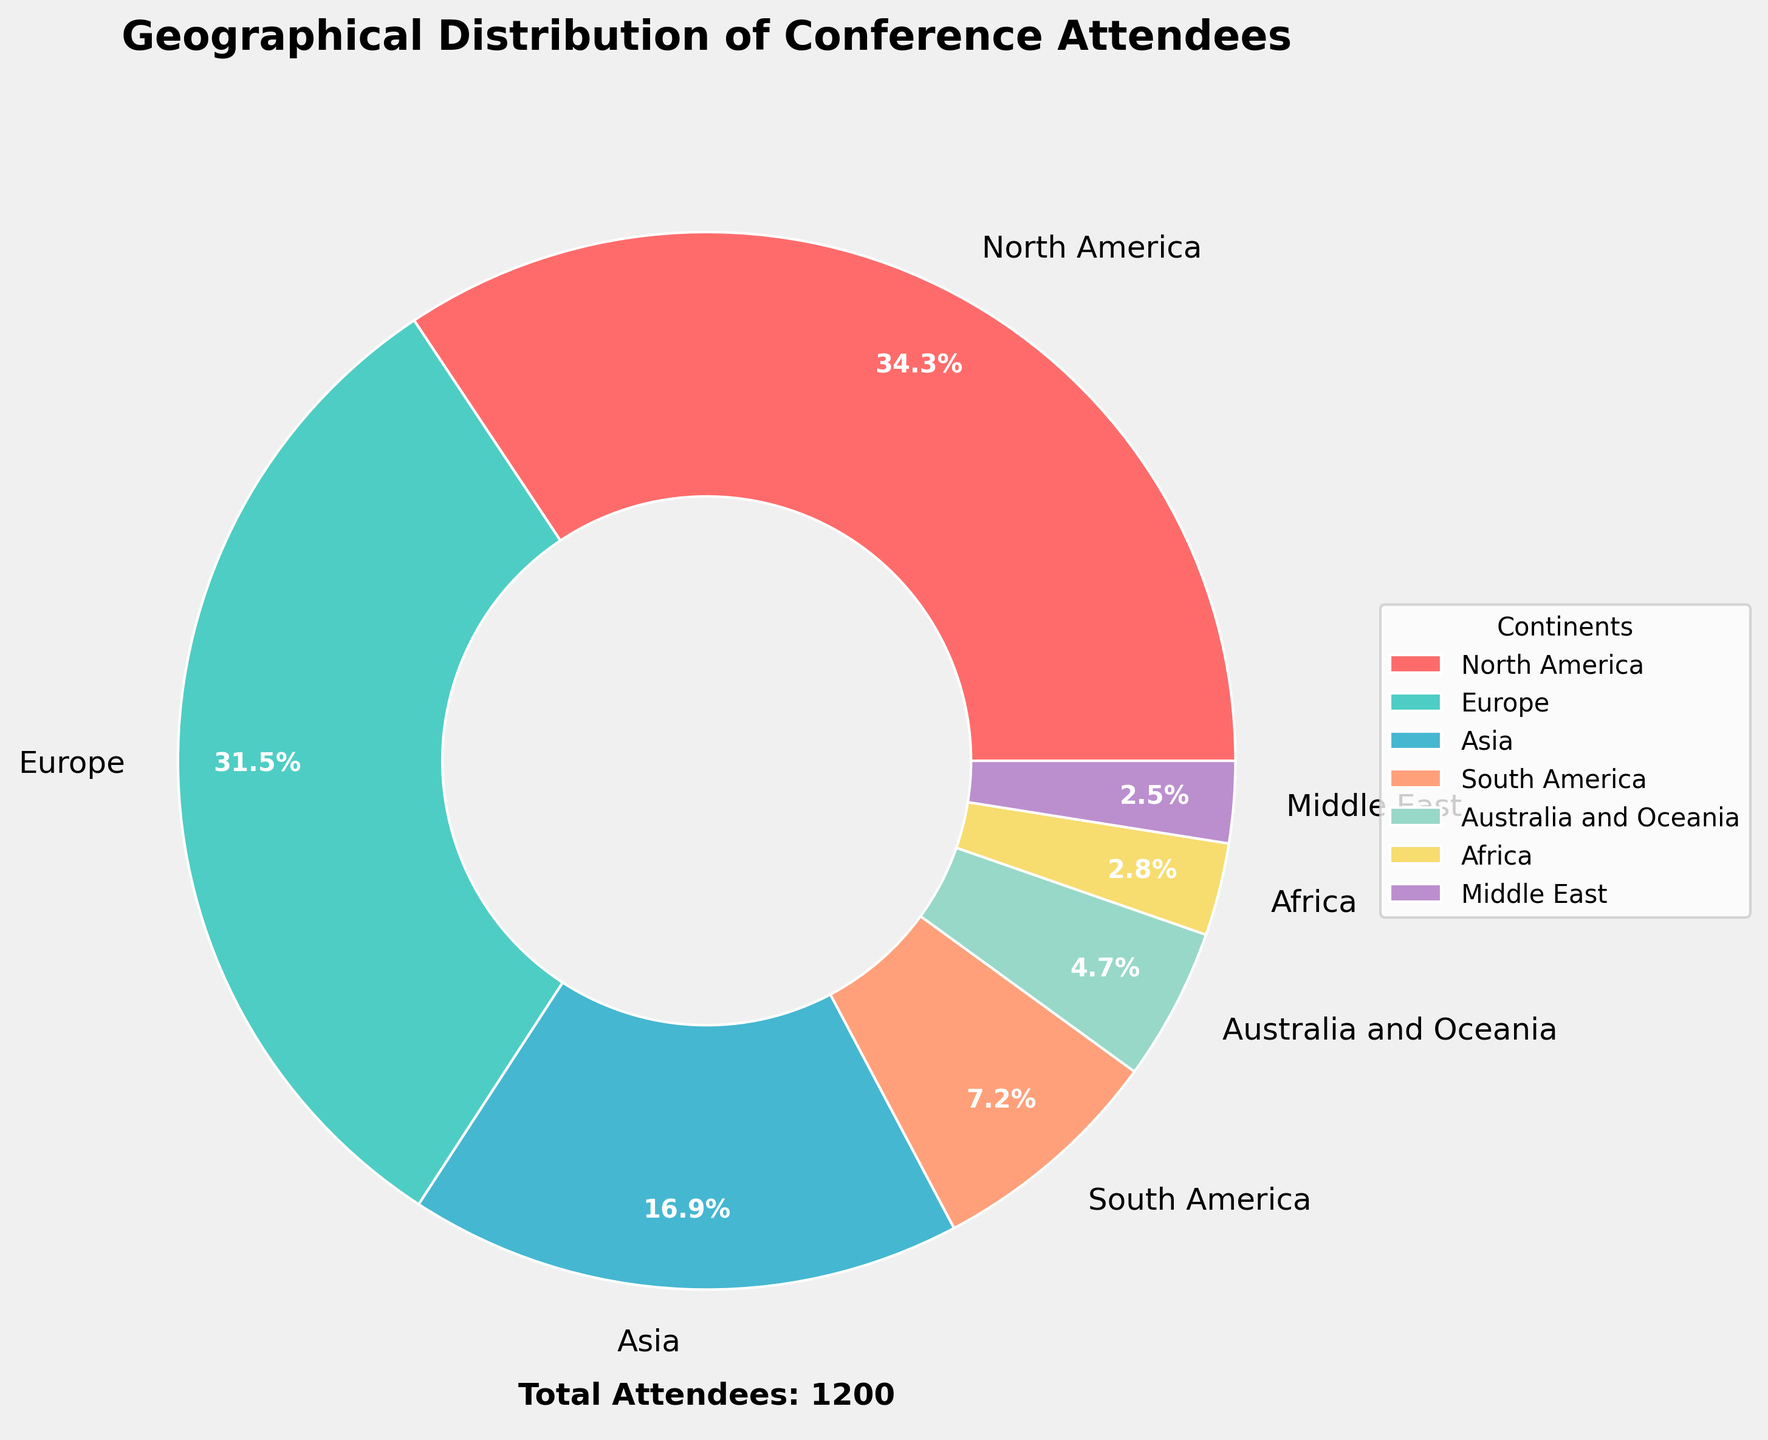Which continent has the highest number of attendees? North America has the largest slice in the pie chart.
Answer: North America Which continent has the lowest number of attendees? The Middle East has the smallest slice in the pie chart.
Answer: Middle East How many more attendees are there from Europe compared to Asia? Europe has 378 attendees and Asia has 203 attendees. Subtracting the number of attendees from Asia from Europe yields 378 - 203 = 175.
Answer: 175 What is the combined percentage of attendees from Africa and the Middle East? Africa has 34 attendees and the Middle East has 30 attendees. The sum is 34 + 30 = 64 attendees. The total number of attendees is 1200. Therefore, the combined percentage is (64/1200) * 100 = 5.3%.
Answer: 5.3% What is the percentage difference in attendees between North America and South America? North America has 412 attendees and South America has 87 attendees. Subtracting South America's attendees from North America's attendees yields 412 - 87 = 325. The percentage difference relative to the total number of attendees (1200) is (325/1200) * 100 = 27.1%.
Answer: 27.1% Rank the continents by the number of attendees from highest to lowest. Observing the slices in the pie chart: 1) North America, 2) Europe, 3) Asia, 4) South America, 5) Australia and Oceania, 6) Africa, 7) Middle East.
Answer: North America, Europe, Asia, South America, Australia and Oceania, Africa, Middle East What visual attribute is used to represent the number of attendees from different continents? The size of each slice in the pie chart represents the number of attendees from each continent; larger slices indicate more attendees.
Answer: Slice size 